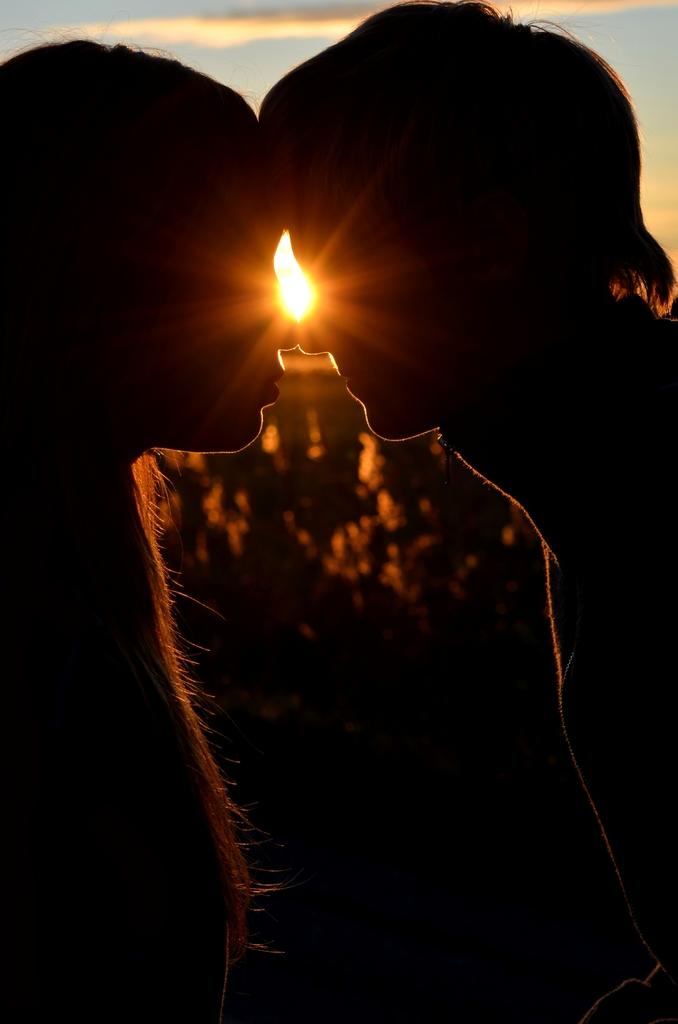How many people are present in the image? There are two persons standing in the image. What is visible in the sky in the image? There is a sun visible in the sky in the image. What type of pump can be seen in the image? There is no pump present in the image. Is there a tiger visible in the image? No, there is no tiger visible in the image. What type of protest is taking place in the image? There is no protest present in the image. 